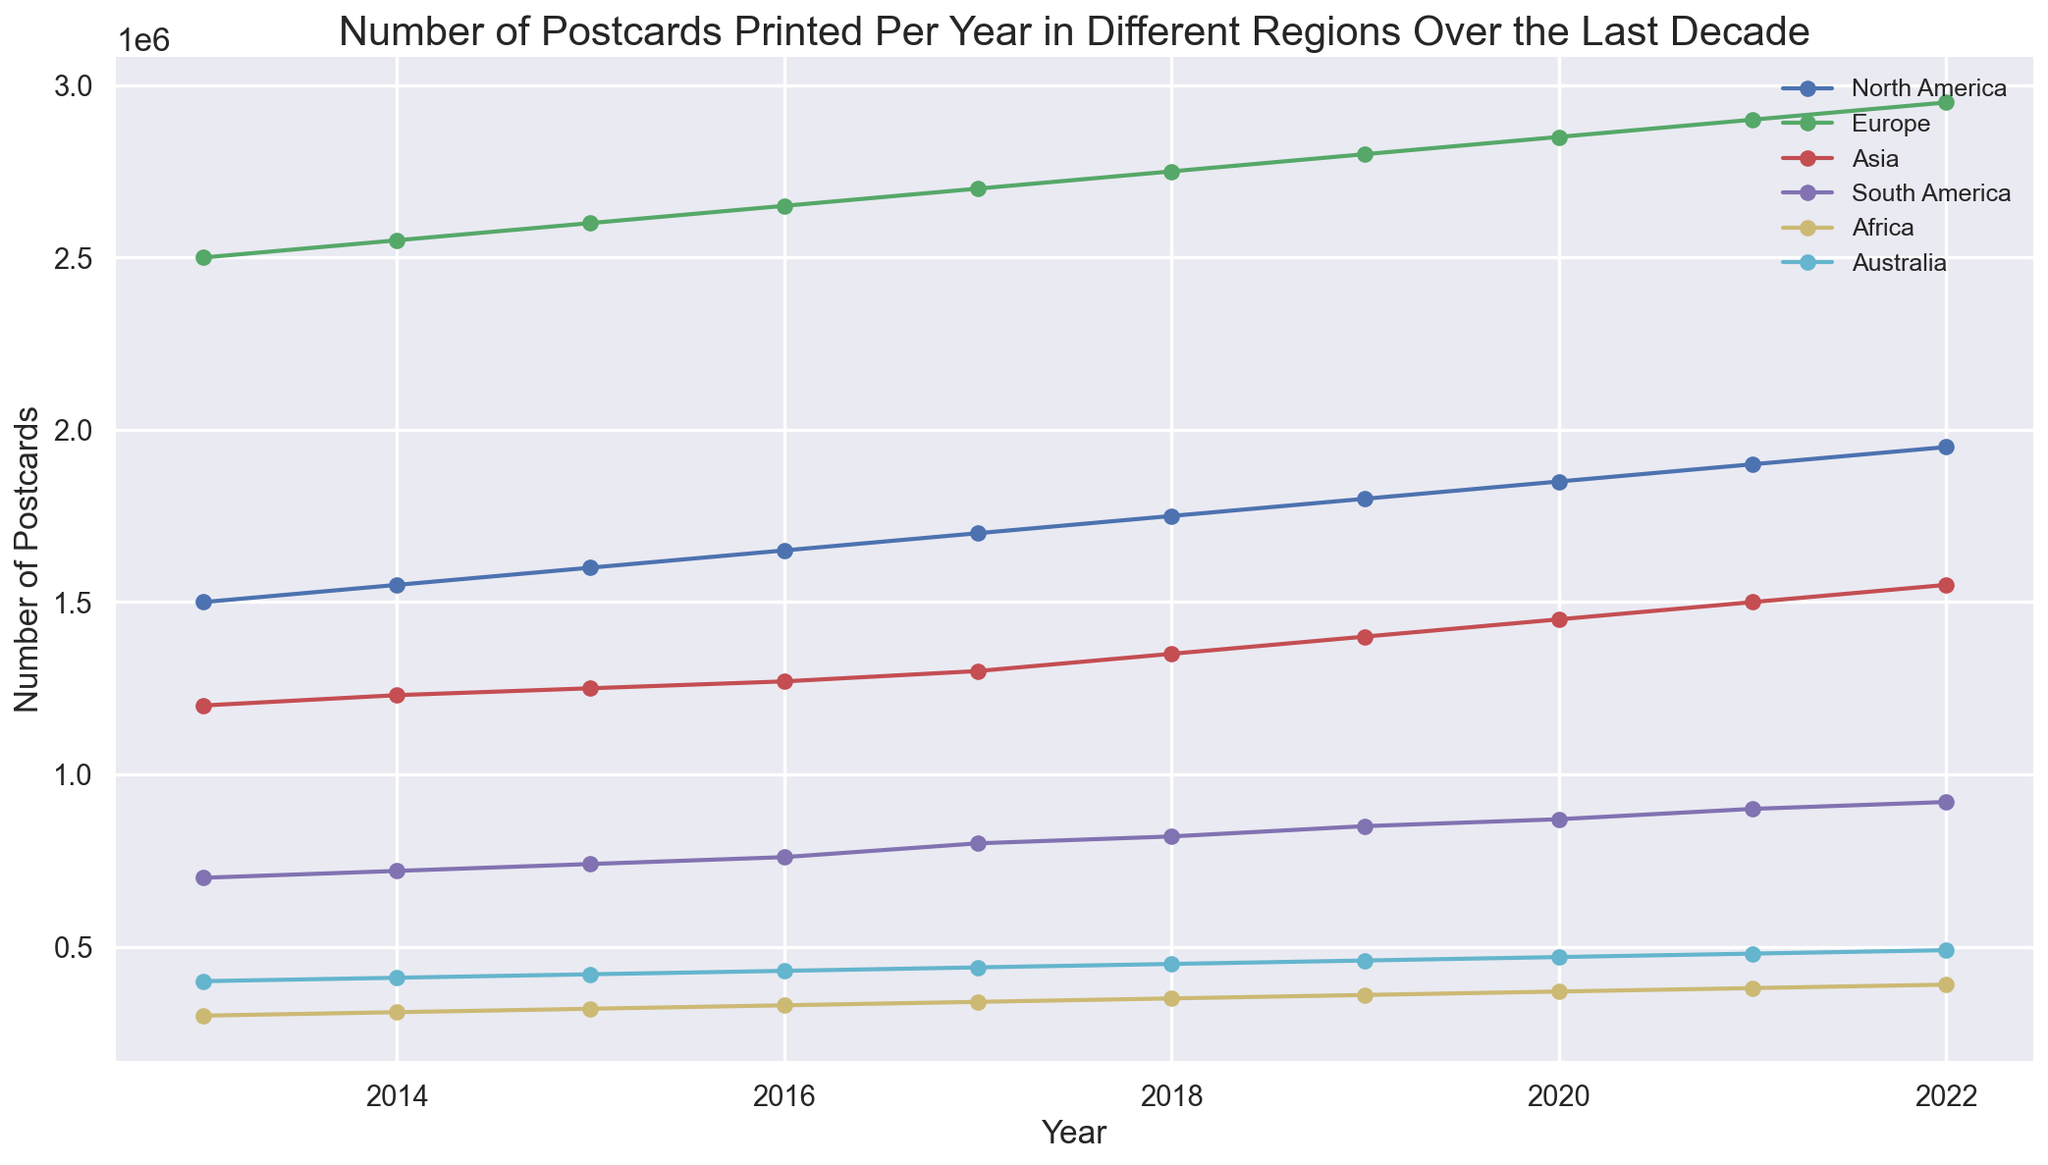What is the total number of postcards printed in Europe in 2020 and 2021 combined? To find this, add the values for Europe in 2020 and 2021. From the figure, Europe had 2,850,000 postcards in 2020 and 2,900,000 postcards in 2021. Therefore, the total is 2,850,000 + 2,900,000 = 5,750,000.
Answer: 5,750,000 Which region had the highest number of postcards printed in 2019? Look at the lines representing each region in 2019 and identify the highest point. The 'Europe' line (blue) is the highest, representing 2,800,000 postcards.
Answer: Europe In which year did North America surpass 1,700,000 postcards printed? Observe the trend line for North America and note the year it crosses the 1,700,000 mark. The line for North America crosses this threshold in 2017.
Answer: 2017 Between Asia and South America, which region saw a larger increase in postcards printed from 2017 to 2022? Subtract the 2017 value from the 2022 value for both Asia and South America and compare the two results. For Asia: 1,550,000 - 1,300,000 = 250,000. For South America: 920,000 - 800,000 = 120,000. Asia had a larger increase.
Answer: Asia Which region has shown a consistent increase in the number of postcards printed every year? Check the trends of all regions and identify which one has a steadily upward slope without any dips. All regions show consistent increases, but let's verify North America as an example. From 2013 to 2022, North America’s printed postcards consistently increased each year.
Answer: North America (and all other regions) What was the average number of postcards printed annually in Africa from 2013 to 2022? Sum the number of postcards printed in Africa for each year from 2013 to 2022 and divide by the number of years (10). The values are 300,000, 310,000, 320,000, 330,000, 340,000, 350,000, 360,000, 370,000, 380,000, 390,000. The sum is 3,550,000. The average is 3,550,000 / 10 = 355,000.
Answer: 355,000 From 2013 to 2022, which region experienced the smallest increase in postcard printing numbers? Calculate the change in the number of postcards printed from 2013 to 2022 for each region. The smallest increase is the one closest to zero. North America: 1,950,000 - 1,500,000 = 450,000; Europe: 2,950,000 - 2,500,000 = 450,000; Asia: 1,550,000 - 1,200,000 = 350,000; South America: 920,000 - 700,000 = 220,000; Africa: 390,000 - 300,000 = 90,000; Australia: 490,000 - 400,000 = 90,000. The smallest increase occurred in Africa and Australia.
Answer: Africa and Australia In which year did Australia see its largest annual increase in the number of postcards printed? Identify the year-to-year increments for Australia and find the largest one. Checking each year for Australia, the largest increase is from 2017 (440,000) to 2018 (450,000), which is 10,000.
Answer: 2017 to 2018 Comparing the number of postcards printed in 2015, how much more was printed in Europe compared to North America? Look at the values for Europe and North America in 2015. For Europe: 2,600,000; for North America: 1,600,000. Subtract the North America value from the Europe value: 2,600,000 - 1,600,000 = 1,000,000.
Answer: 1,000,000 Which region's trend line has the steepest slope from 2018 to 2020? Compare the slopes of the trend lines for each region between 2018 and 2020. The slope is the steepness or incline of the line. Europe and North America have the steepest slopes as their increases are the largest.
Answer: Europe 